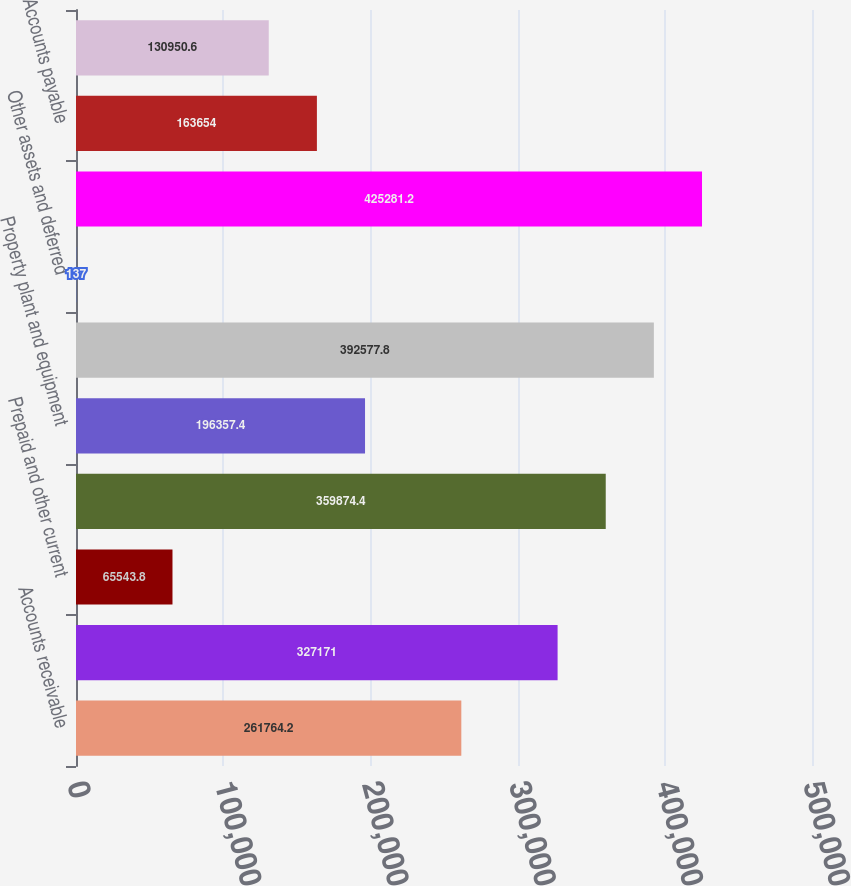Convert chart to OTSL. <chart><loc_0><loc_0><loc_500><loc_500><bar_chart><fcel>Accounts receivable<fcel>Inventories net<fcel>Prepaid and other current<fcel>Total current assets<fcel>Property plant and equipment<fcel>Goodwill and intangible assets<fcel>Other assets and deferred<fcel>Total assets<fcel>Accounts payable<fcel>Other current liabilities<nl><fcel>261764<fcel>327171<fcel>65543.8<fcel>359874<fcel>196357<fcel>392578<fcel>137<fcel>425281<fcel>163654<fcel>130951<nl></chart> 